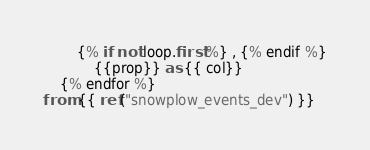<code> <loc_0><loc_0><loc_500><loc_500><_SQL_>        {% if not loop.first %} , {% endif %}
            {{prop}} as {{ col}}
    {% endfor %}
from {{ ref("snowplow_events_dev") }}</code> 